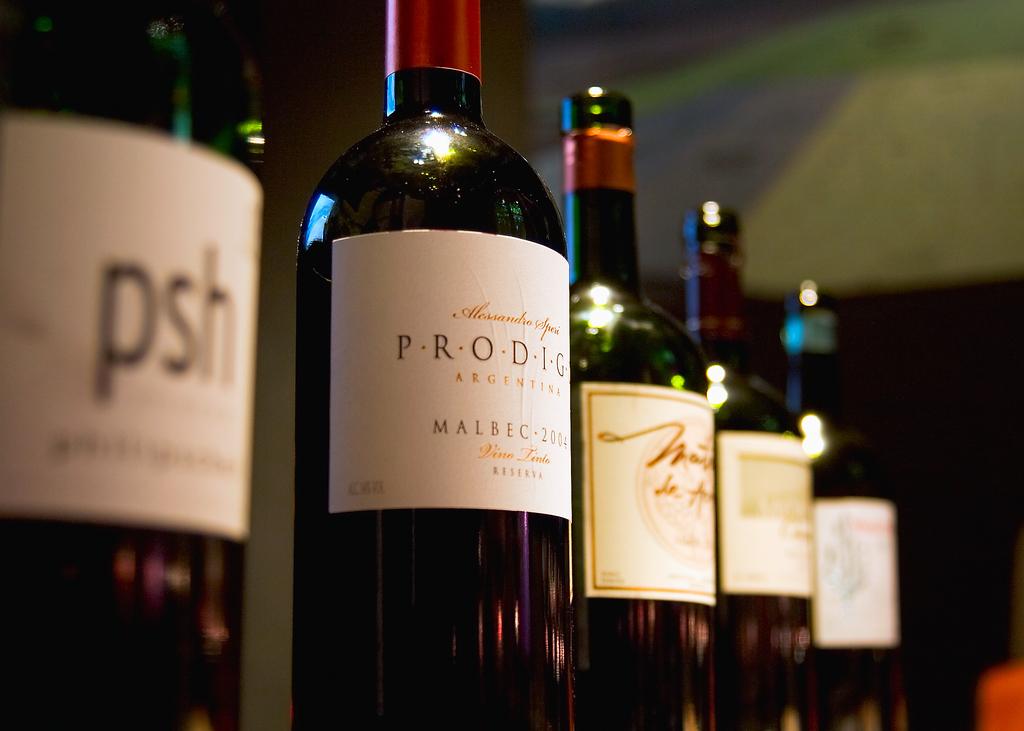What country is the prodigy wine from?
Keep it short and to the point. Argentina. What are the three letters on the label to the far left?
Give a very brief answer. Psh. 